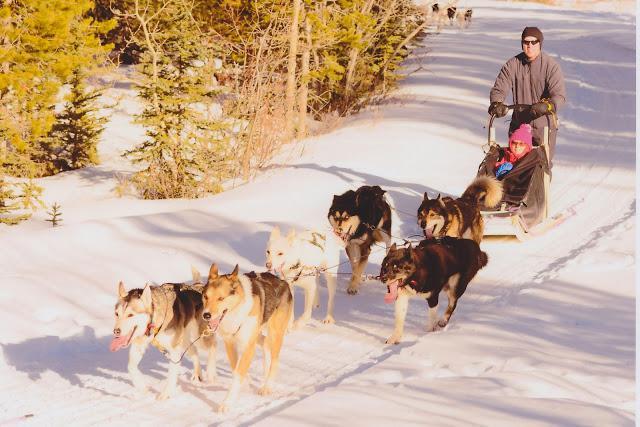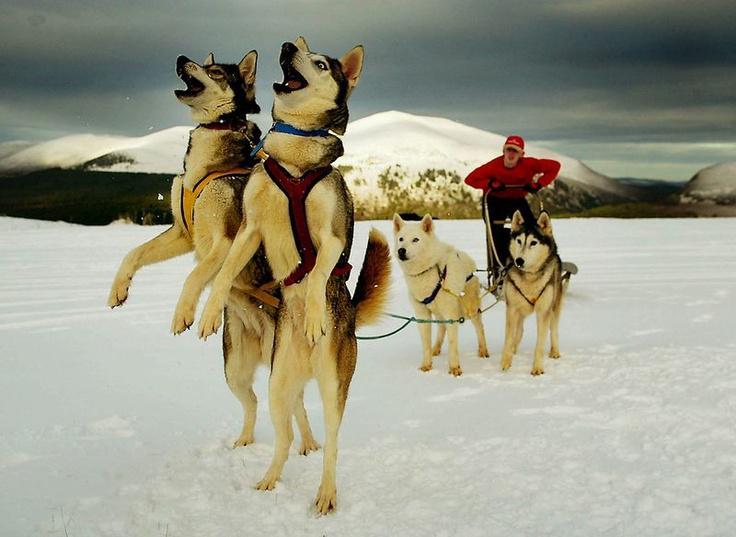The first image is the image on the left, the second image is the image on the right. Examine the images to the left and right. Is the description "In only one of the two images are the dogs awake." accurate? Answer yes or no. No. The first image is the image on the left, the second image is the image on the right. For the images displayed, is the sentence "One image shows a team of dogs hitched to a sled, and the other image shows a brown, non-husky dog posed with a sled but not hitched to pull it." factually correct? Answer yes or no. No. 